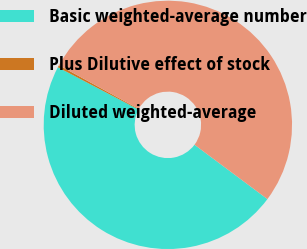<chart> <loc_0><loc_0><loc_500><loc_500><pie_chart><fcel>Basic weighted-average number<fcel>Plus Dilutive effect of stock<fcel>Diluted weighted-average<nl><fcel>47.48%<fcel>0.3%<fcel>52.22%<nl></chart> 